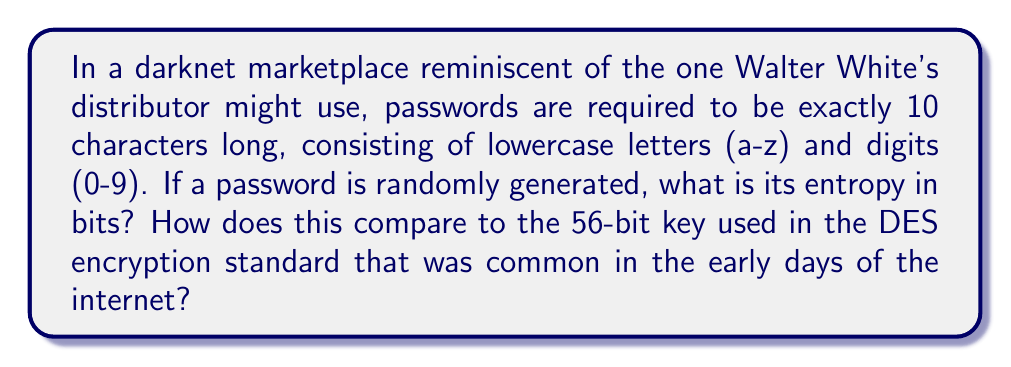Provide a solution to this math problem. Let's approach this step-by-step:

1) First, we need to calculate the number of possible characters in the password:
   - 26 lowercase letters
   - 10 digits
   Total: 26 + 10 = 36 possible characters

2) The entropy of a randomly generated password is calculated using the formula:
   $$ H = L \log_2(N) $$
   Where:
   $H$ is the entropy in bits
   $L$ is the length of the password
   $N$ is the number of possible characters

3) In this case:
   $L = 10$ (password length)
   $N = 36$ (possible characters)

4) Plugging these values into the formula:
   $$ H = 10 \log_2(36) $$

5) Calculate:
   $$ H = 10 * 5.17 = 51.7 \text{ bits} $$

6) Comparing to DES:
   51.7 bits < 56 bits

   This means the password entropy is slightly lower than the key strength of DES.
Answer: 51.7 bits, which is weaker than DES 